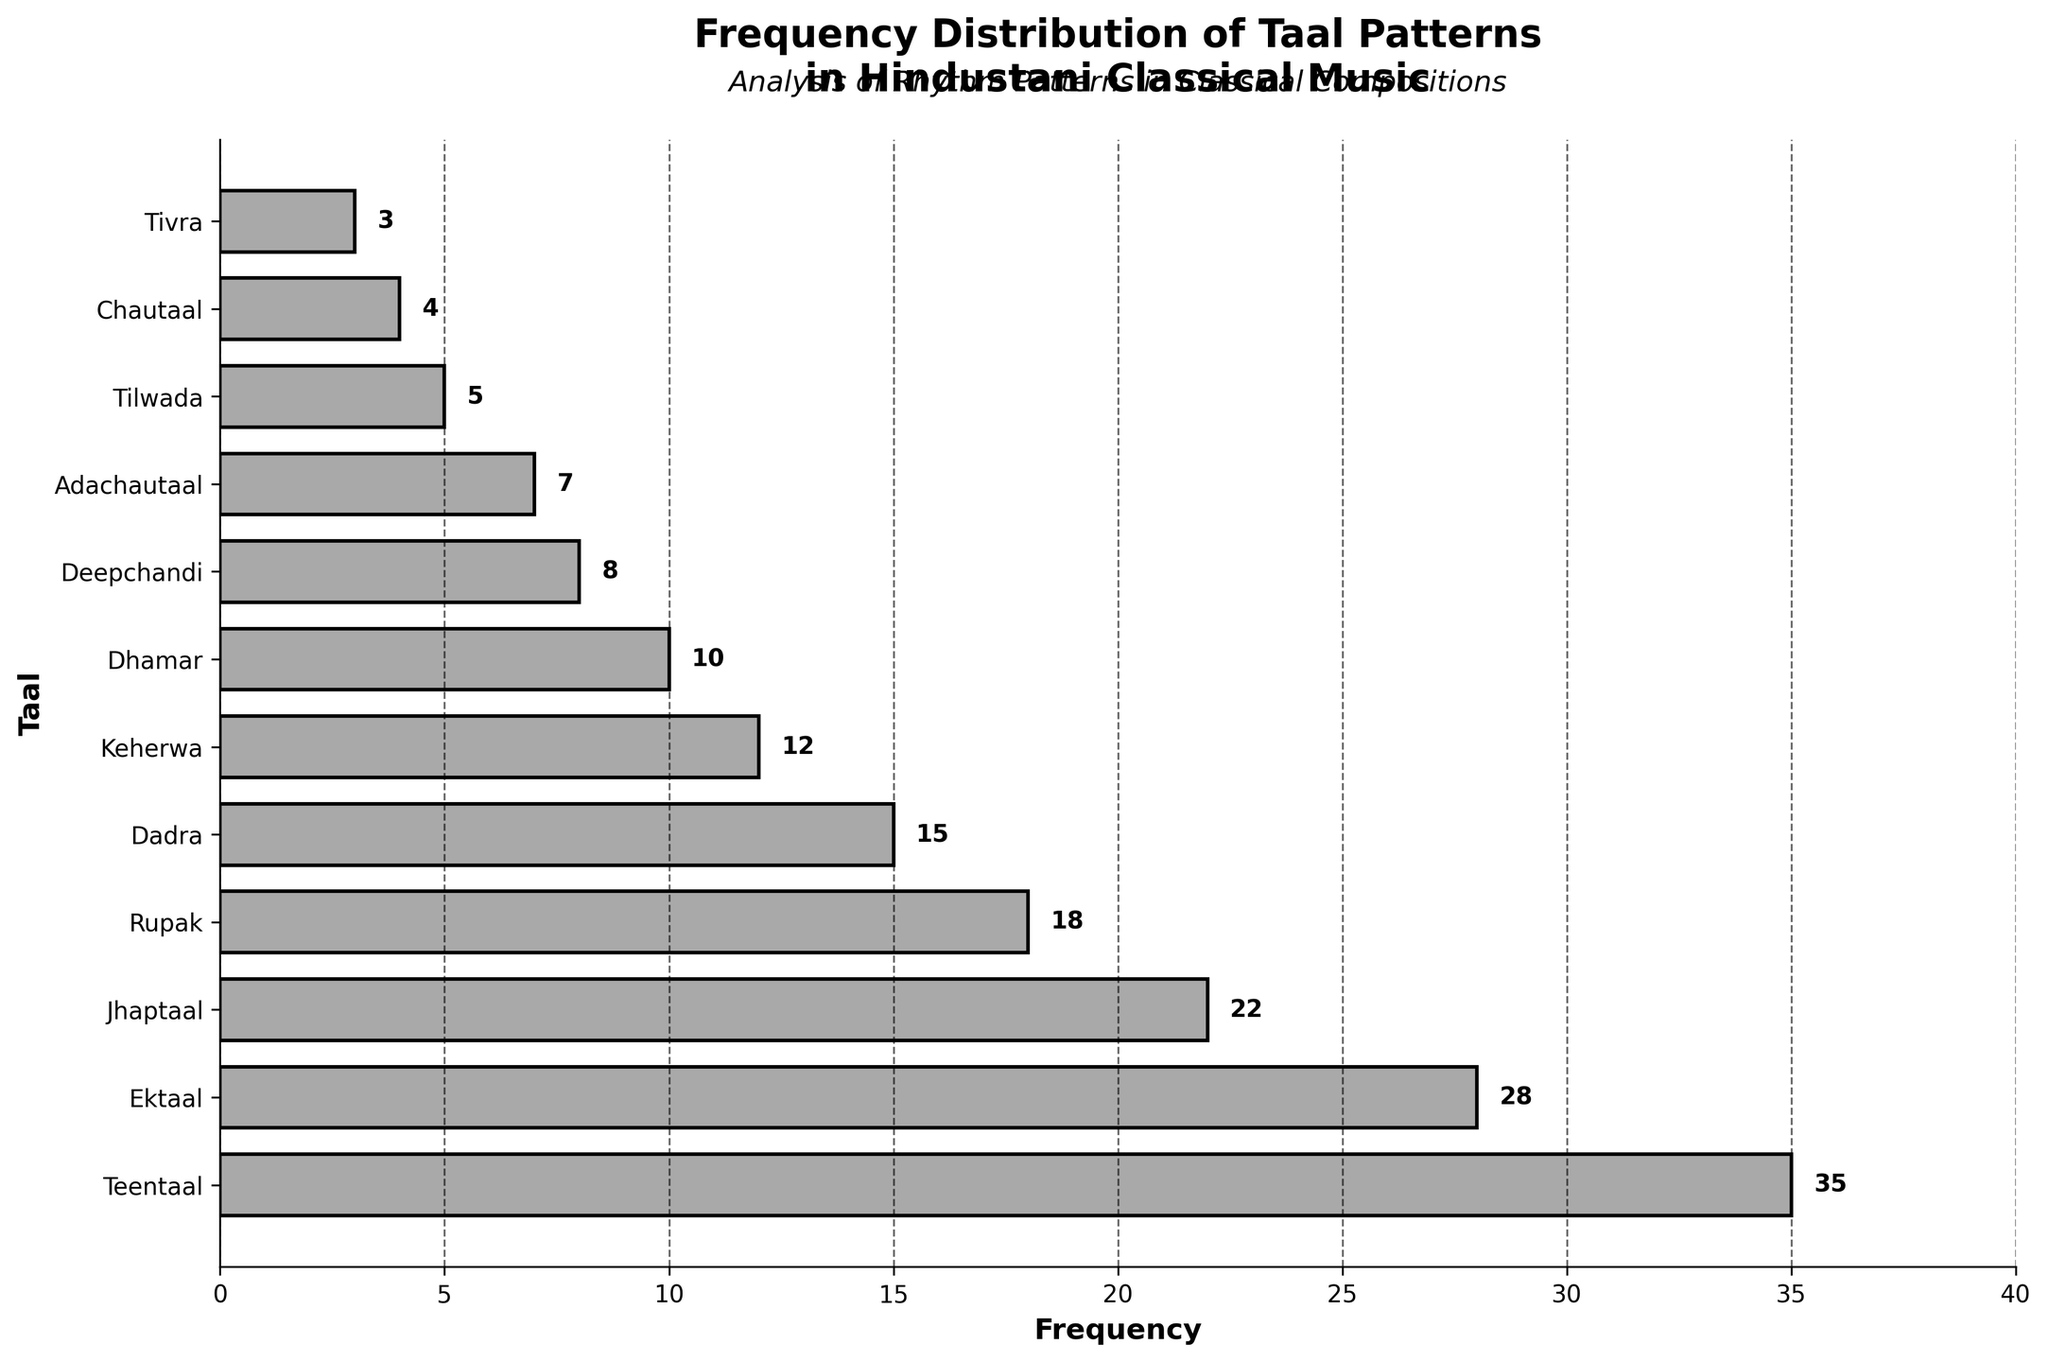What is the most frequently used taal pattern in the figure? By looking at the horizontal bars, the Teentaal bar is the longest one, indicating it has the highest frequency.
Answer: Teentaal What does the x-axis represent in the figure? The x-axis has labels like 5, 10, 15, etc., representing the frequency of each taal pattern.
Answer: Frequency How many taal patterns have a frequency greater than 20? By observing the figure, Teentaal (35), Ektaal (28), and Jhaptaal (22) each have frequencies above 20. This counts to three.
Answer: Three What is the frequency of Dadra? Locate the bar labeled Dadra on the y-axis and look at its length on the x-axis, which is 15.
Answer: 15 Which taal pattern has the lowest frequency? Among the bars, the one labeled Tivra is the shortest, signifying that Tivra has the lowest frequency.
Answer: Tivra What is the combined frequency of Teentaal and Jhaptaal? Teentaal has a frequency of 35 and Jhaptaal has 22. Adding them gives 35 + 22 = 57.
Answer: 57 How does the frequency of Deepchandi compare to that of Dhamar? The frequency of Deepchandi is 8, while Dhamar's frequency is 10. Therefore, Deepchandi is less frequent than Dhamar.
Answer: Less frequent What is the title of the figure? The title is located at the top of the figure and reads, "Frequency Distribution of Taal Patterns in Hindustani Classical Music".
Answer: Frequency Distribution of Taal Patterns in Hindustani Classical Music Which two taal patterns have an equal frequency of 10 or more? By examining the figure, it is evident that Ektaal (28) and Jhaptaal (22) both have frequencies exceeding 10, while Dadra has 15. None have exactly equal values, so this is a trick question.
Answer: None 